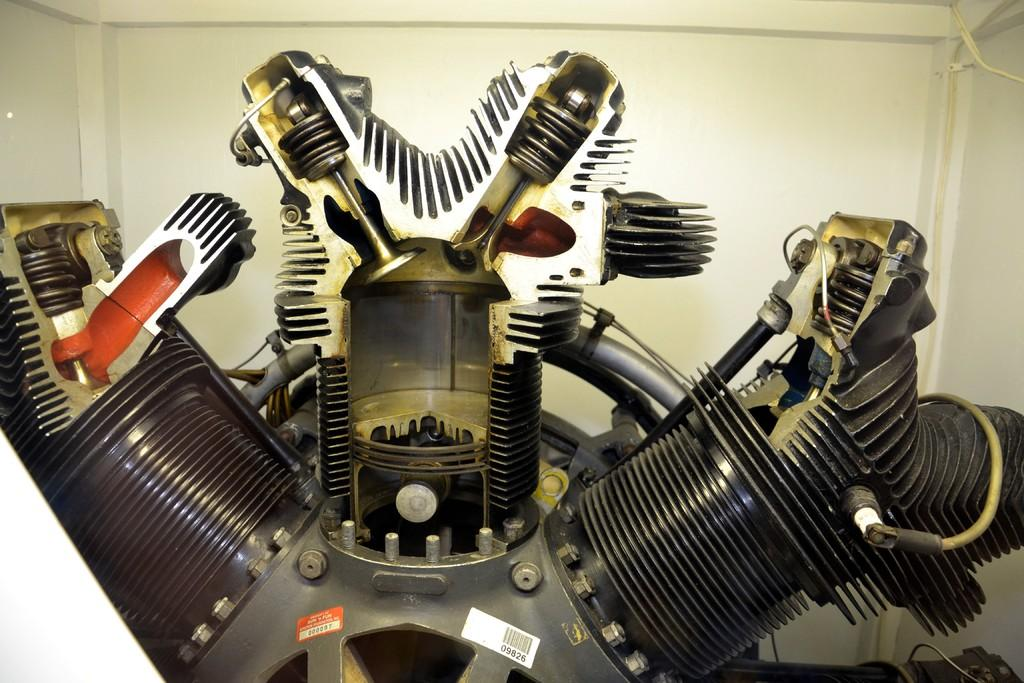What is the main subject of the image? The main subject of the image is a machine tool. Can you describe the setting of the image? There is a wall visible in the background of the image. What type of knee injury can be seen in the image? There is no knee injury present in the image; it features a machine tool and a wall in the background. What is the flame used for in the image? There is no flame present in the image. 